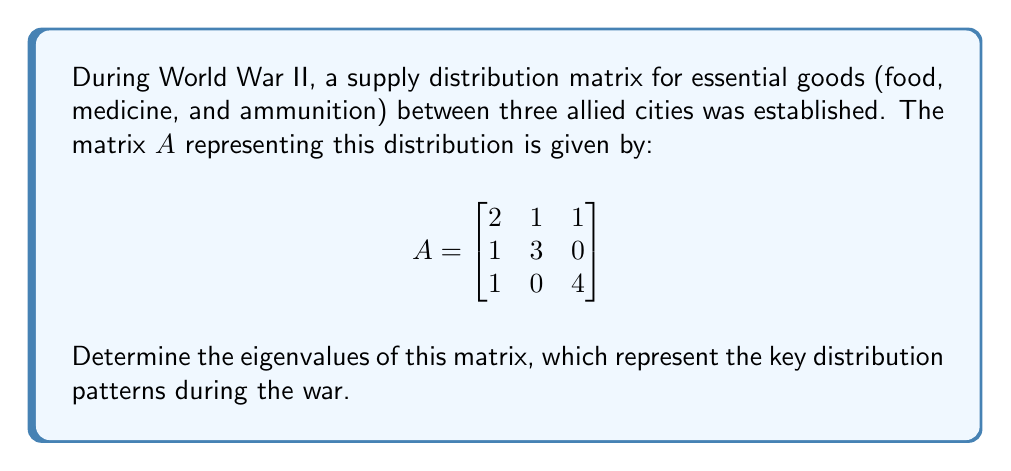Can you answer this question? To find the eigenvalues of matrix $A$, we need to solve the characteristic equation:

1) First, we set up the equation $det(A - \lambda I) = 0$, where $I$ is the 3x3 identity matrix:

   $$det\begin{pmatrix}
   2-\lambda & 1 & 1 \\
   1 & 3-\lambda & 0 \\
   1 & 0 & 4-\lambda
   \end{pmatrix} = 0$$

2) Expand the determinant:
   $$(2-\lambda)[(3-\lambda)(4-\lambda) - 0] - 1[1(4-\lambda) - 0] + 1[1(0) - 1(3-\lambda)] = 0$$

3) Simplify:
   $$(2-\lambda)(12-7\lambda+\lambda^2) - (4-\lambda) + (3-\lambda) = 0$$

4) Expand:
   $$24 - 14\lambda + 2\lambda^2 - 12\lambda + 7\lambda^2 - \lambda^3 - 4 + \lambda + 3 - \lambda = 0$$

5) Collect like terms:
   $$-\lambda^3 + 9\lambda^2 - 26\lambda + 23 = 0$$

6) This is a cubic equation. We can factor out $(\lambda - 1)$:
   $$(\lambda - 1)(-\lambda^2 + 8\lambda - 23) = 0$$

7) Using the quadratic formula for $-\lambda^2 + 8\lambda - 23 = 0$, we get:
   $$\lambda = \frac{8 \pm \sqrt{64 + 92}}{2} = \frac{8 \pm \sqrt{156}}{2} = 4 \pm \sqrt{39}$$

Therefore, the eigenvalues are:
$\lambda_1 = 1$, $\lambda_2 = 4 + \sqrt{39}$, and $\lambda_3 = 4 - \sqrt{39}$
Answer: $\lambda_1 = 1$, $\lambda_2 = 4 + \sqrt{39}$, $\lambda_3 = 4 - \sqrt{39}$ 